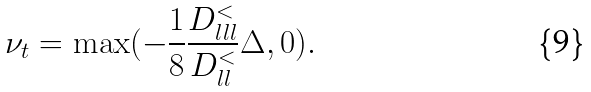<formula> <loc_0><loc_0><loc_500><loc_500>\nu _ { t } = \max ( - \frac { 1 } { 8 } \frac { D _ { l l l } ^ { < } } { D _ { l l } ^ { < } } \Delta , 0 ) .</formula> 